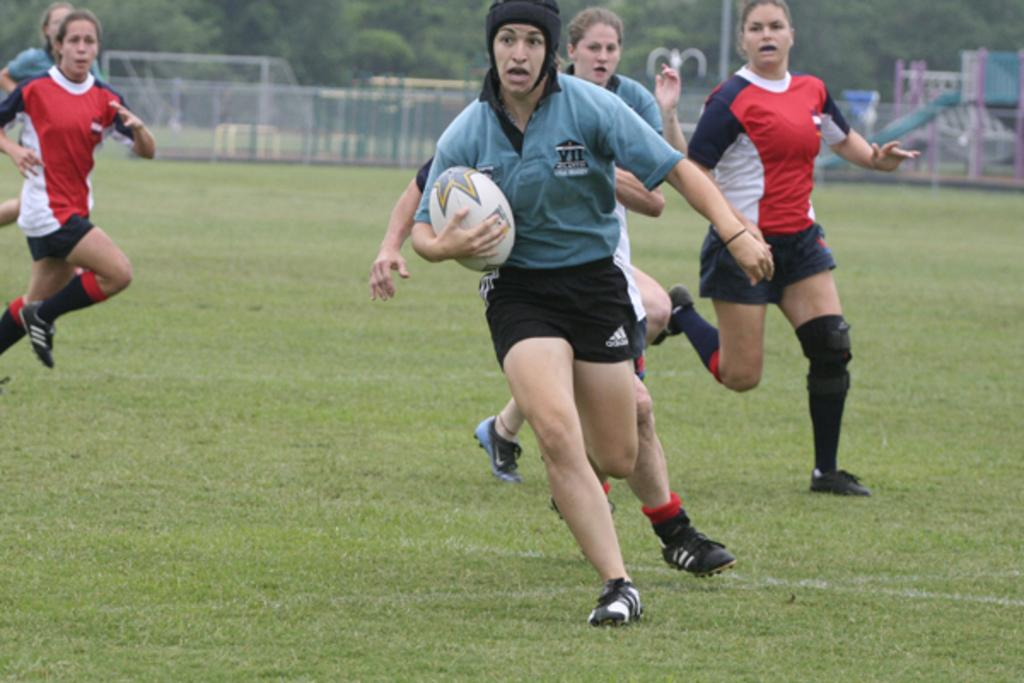What are the people in the image doing? The people in the image are playing. What object is being held by one of the people? A person is holding a ball. What can be seen in the image that separates the playing area? There is a fence in the image. What is visible in the background of the image? There are objects and trees present in the background of the image. How many sheep can be seen grazing in the background of the image? There are no sheep present in the image; only objects and trees can be seen in the background. 